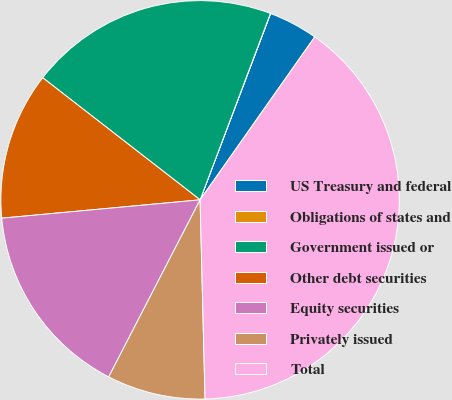Convert chart to OTSL. <chart><loc_0><loc_0><loc_500><loc_500><pie_chart><fcel>US Treasury and federal<fcel>Obligations of states and<fcel>Government issued or<fcel>Other debt securities<fcel>Equity securities<fcel>Privately issued<fcel>Total<nl><fcel>4.0%<fcel>0.02%<fcel>20.24%<fcel>11.97%<fcel>15.95%<fcel>7.98%<fcel>39.85%<nl></chart> 